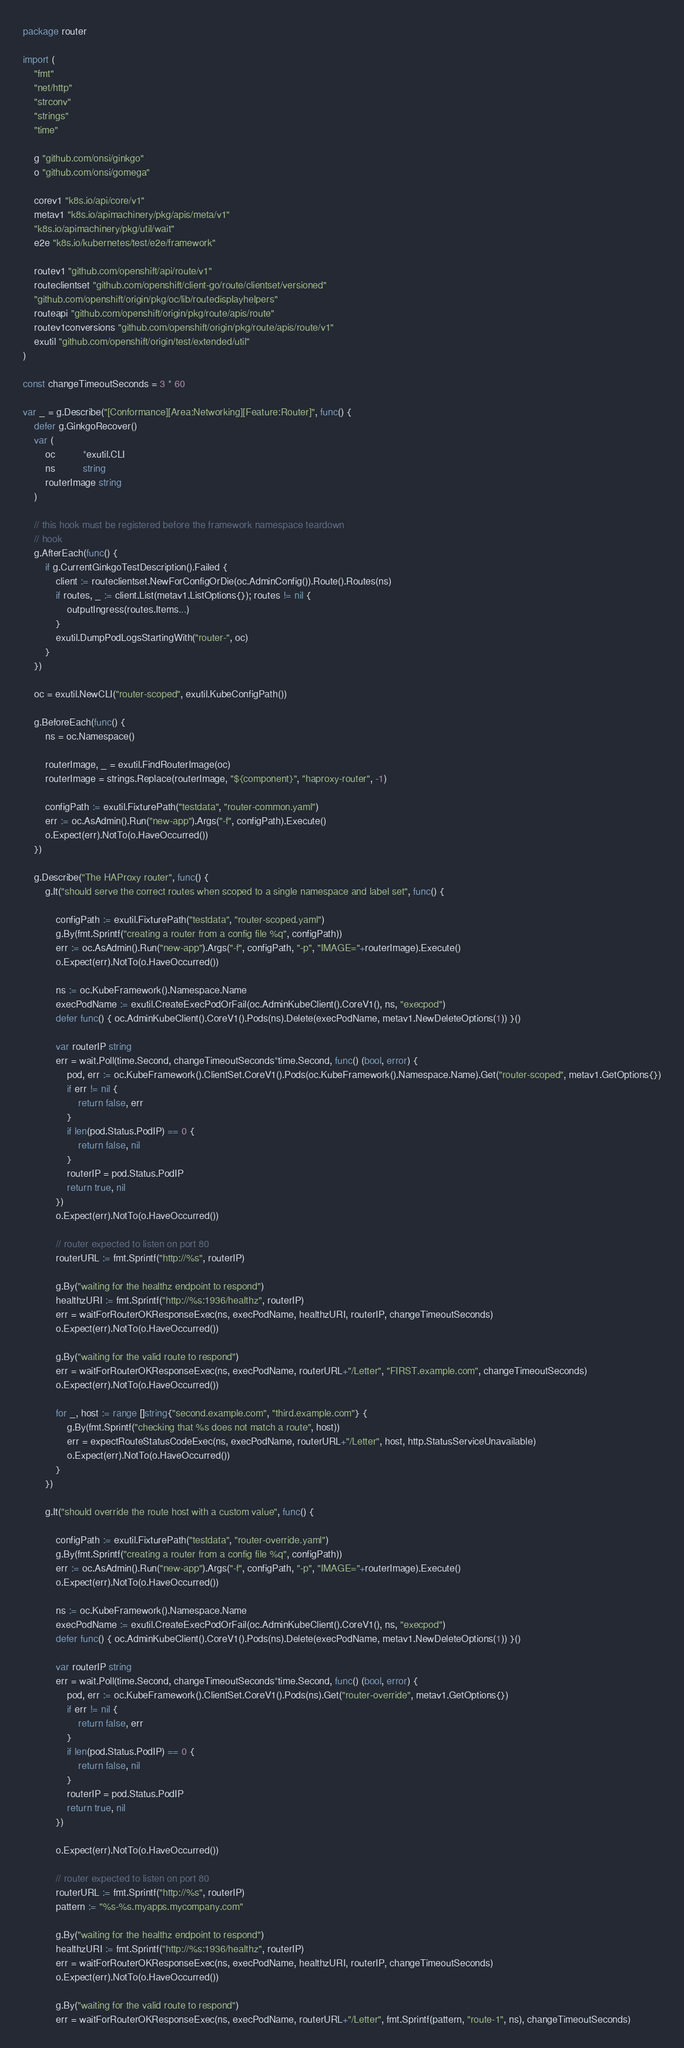<code> <loc_0><loc_0><loc_500><loc_500><_Go_>package router

import (
	"fmt"
	"net/http"
	"strconv"
	"strings"
	"time"

	g "github.com/onsi/ginkgo"
	o "github.com/onsi/gomega"

	corev1 "k8s.io/api/core/v1"
	metav1 "k8s.io/apimachinery/pkg/apis/meta/v1"
	"k8s.io/apimachinery/pkg/util/wait"
	e2e "k8s.io/kubernetes/test/e2e/framework"

	routev1 "github.com/openshift/api/route/v1"
	routeclientset "github.com/openshift/client-go/route/clientset/versioned"
	"github.com/openshift/origin/pkg/oc/lib/routedisplayhelpers"
	routeapi "github.com/openshift/origin/pkg/route/apis/route"
	routev1conversions "github.com/openshift/origin/pkg/route/apis/route/v1"
	exutil "github.com/openshift/origin/test/extended/util"
)

const changeTimeoutSeconds = 3 * 60

var _ = g.Describe("[Conformance][Area:Networking][Feature:Router]", func() {
	defer g.GinkgoRecover()
	var (
		oc          *exutil.CLI
		ns          string
		routerImage string
	)

	// this hook must be registered before the framework namespace teardown
	// hook
	g.AfterEach(func() {
		if g.CurrentGinkgoTestDescription().Failed {
			client := routeclientset.NewForConfigOrDie(oc.AdminConfig()).Route().Routes(ns)
			if routes, _ := client.List(metav1.ListOptions{}); routes != nil {
				outputIngress(routes.Items...)
			}
			exutil.DumpPodLogsStartingWith("router-", oc)
		}
	})

	oc = exutil.NewCLI("router-scoped", exutil.KubeConfigPath())

	g.BeforeEach(func() {
		ns = oc.Namespace()

		routerImage, _ = exutil.FindRouterImage(oc)
		routerImage = strings.Replace(routerImage, "${component}", "haproxy-router", -1)

		configPath := exutil.FixturePath("testdata", "router-common.yaml")
		err := oc.AsAdmin().Run("new-app").Args("-f", configPath).Execute()
		o.Expect(err).NotTo(o.HaveOccurred())
	})

	g.Describe("The HAProxy router", func() {
		g.It("should serve the correct routes when scoped to a single namespace and label set", func() {

			configPath := exutil.FixturePath("testdata", "router-scoped.yaml")
			g.By(fmt.Sprintf("creating a router from a config file %q", configPath))
			err := oc.AsAdmin().Run("new-app").Args("-f", configPath, "-p", "IMAGE="+routerImage).Execute()
			o.Expect(err).NotTo(o.HaveOccurred())

			ns := oc.KubeFramework().Namespace.Name
			execPodName := exutil.CreateExecPodOrFail(oc.AdminKubeClient().CoreV1(), ns, "execpod")
			defer func() { oc.AdminKubeClient().CoreV1().Pods(ns).Delete(execPodName, metav1.NewDeleteOptions(1)) }()

			var routerIP string
			err = wait.Poll(time.Second, changeTimeoutSeconds*time.Second, func() (bool, error) {
				pod, err := oc.KubeFramework().ClientSet.CoreV1().Pods(oc.KubeFramework().Namespace.Name).Get("router-scoped", metav1.GetOptions{})
				if err != nil {
					return false, err
				}
				if len(pod.Status.PodIP) == 0 {
					return false, nil
				}
				routerIP = pod.Status.PodIP
				return true, nil
			})
			o.Expect(err).NotTo(o.HaveOccurred())

			// router expected to listen on port 80
			routerURL := fmt.Sprintf("http://%s", routerIP)

			g.By("waiting for the healthz endpoint to respond")
			healthzURI := fmt.Sprintf("http://%s:1936/healthz", routerIP)
			err = waitForRouterOKResponseExec(ns, execPodName, healthzURI, routerIP, changeTimeoutSeconds)
			o.Expect(err).NotTo(o.HaveOccurred())

			g.By("waiting for the valid route to respond")
			err = waitForRouterOKResponseExec(ns, execPodName, routerURL+"/Letter", "FIRST.example.com", changeTimeoutSeconds)
			o.Expect(err).NotTo(o.HaveOccurred())

			for _, host := range []string{"second.example.com", "third.example.com"} {
				g.By(fmt.Sprintf("checking that %s does not match a route", host))
				err = expectRouteStatusCodeExec(ns, execPodName, routerURL+"/Letter", host, http.StatusServiceUnavailable)
				o.Expect(err).NotTo(o.HaveOccurred())
			}
		})

		g.It("should override the route host with a custom value", func() {

			configPath := exutil.FixturePath("testdata", "router-override.yaml")
			g.By(fmt.Sprintf("creating a router from a config file %q", configPath))
			err := oc.AsAdmin().Run("new-app").Args("-f", configPath, "-p", "IMAGE="+routerImage).Execute()
			o.Expect(err).NotTo(o.HaveOccurred())

			ns := oc.KubeFramework().Namespace.Name
			execPodName := exutil.CreateExecPodOrFail(oc.AdminKubeClient().CoreV1(), ns, "execpod")
			defer func() { oc.AdminKubeClient().CoreV1().Pods(ns).Delete(execPodName, metav1.NewDeleteOptions(1)) }()

			var routerIP string
			err = wait.Poll(time.Second, changeTimeoutSeconds*time.Second, func() (bool, error) {
				pod, err := oc.KubeFramework().ClientSet.CoreV1().Pods(ns).Get("router-override", metav1.GetOptions{})
				if err != nil {
					return false, err
				}
				if len(pod.Status.PodIP) == 0 {
					return false, nil
				}
				routerIP = pod.Status.PodIP
				return true, nil
			})

			o.Expect(err).NotTo(o.HaveOccurred())

			// router expected to listen on port 80
			routerURL := fmt.Sprintf("http://%s", routerIP)
			pattern := "%s-%s.myapps.mycompany.com"

			g.By("waiting for the healthz endpoint to respond")
			healthzURI := fmt.Sprintf("http://%s:1936/healthz", routerIP)
			err = waitForRouterOKResponseExec(ns, execPodName, healthzURI, routerIP, changeTimeoutSeconds)
			o.Expect(err).NotTo(o.HaveOccurred())

			g.By("waiting for the valid route to respond")
			err = waitForRouterOKResponseExec(ns, execPodName, routerURL+"/Letter", fmt.Sprintf(pattern, "route-1", ns), changeTimeoutSeconds)</code> 